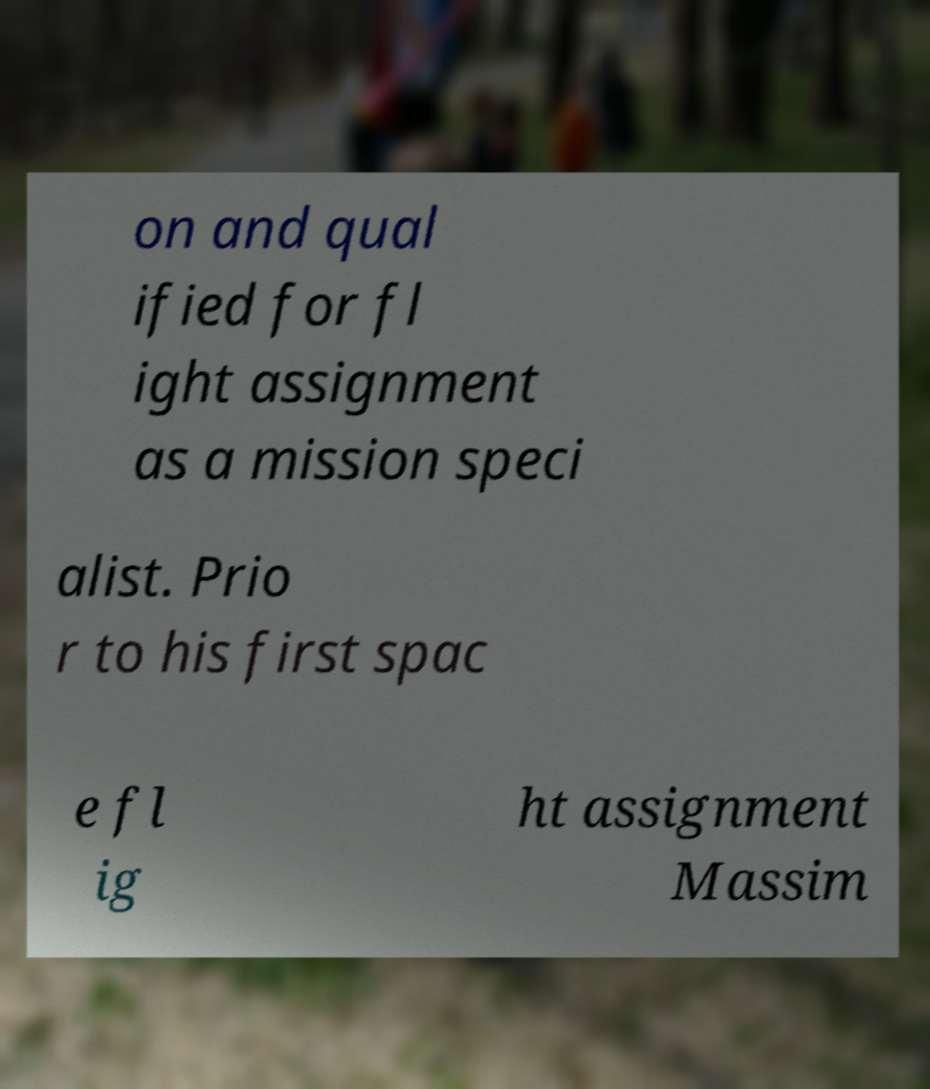I need the written content from this picture converted into text. Can you do that? on and qual ified for fl ight assignment as a mission speci alist. Prio r to his first spac e fl ig ht assignment Massim 